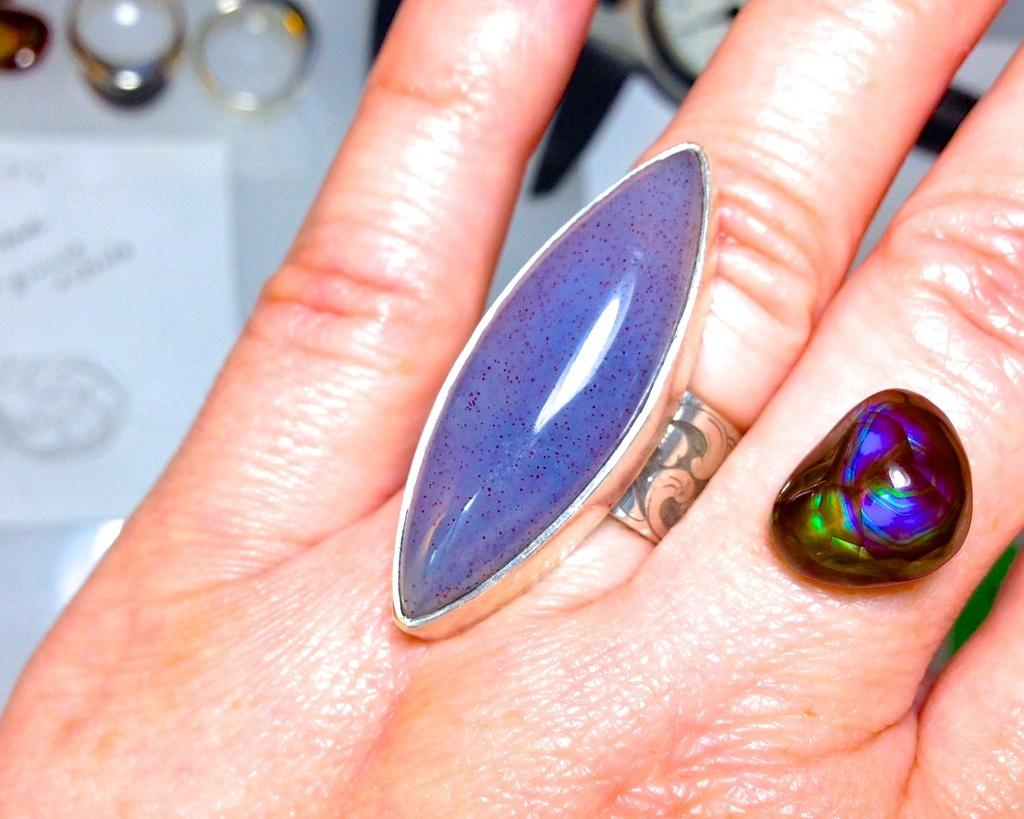What part of a person is visible in the image? There is a hand of a person in the image. What accessory is the person wearing on their hand? The person is wearing a ring on their finger. What can be seen in the top right corner of the image? There are rings visible in the top right corner of the image, and there is also a paper on a surface. What river is flowing through the image? There is no river present in the image. What direction is the person facing in the image? The image only shows a hand, so it is impossible to determine the direction the person is facing. 